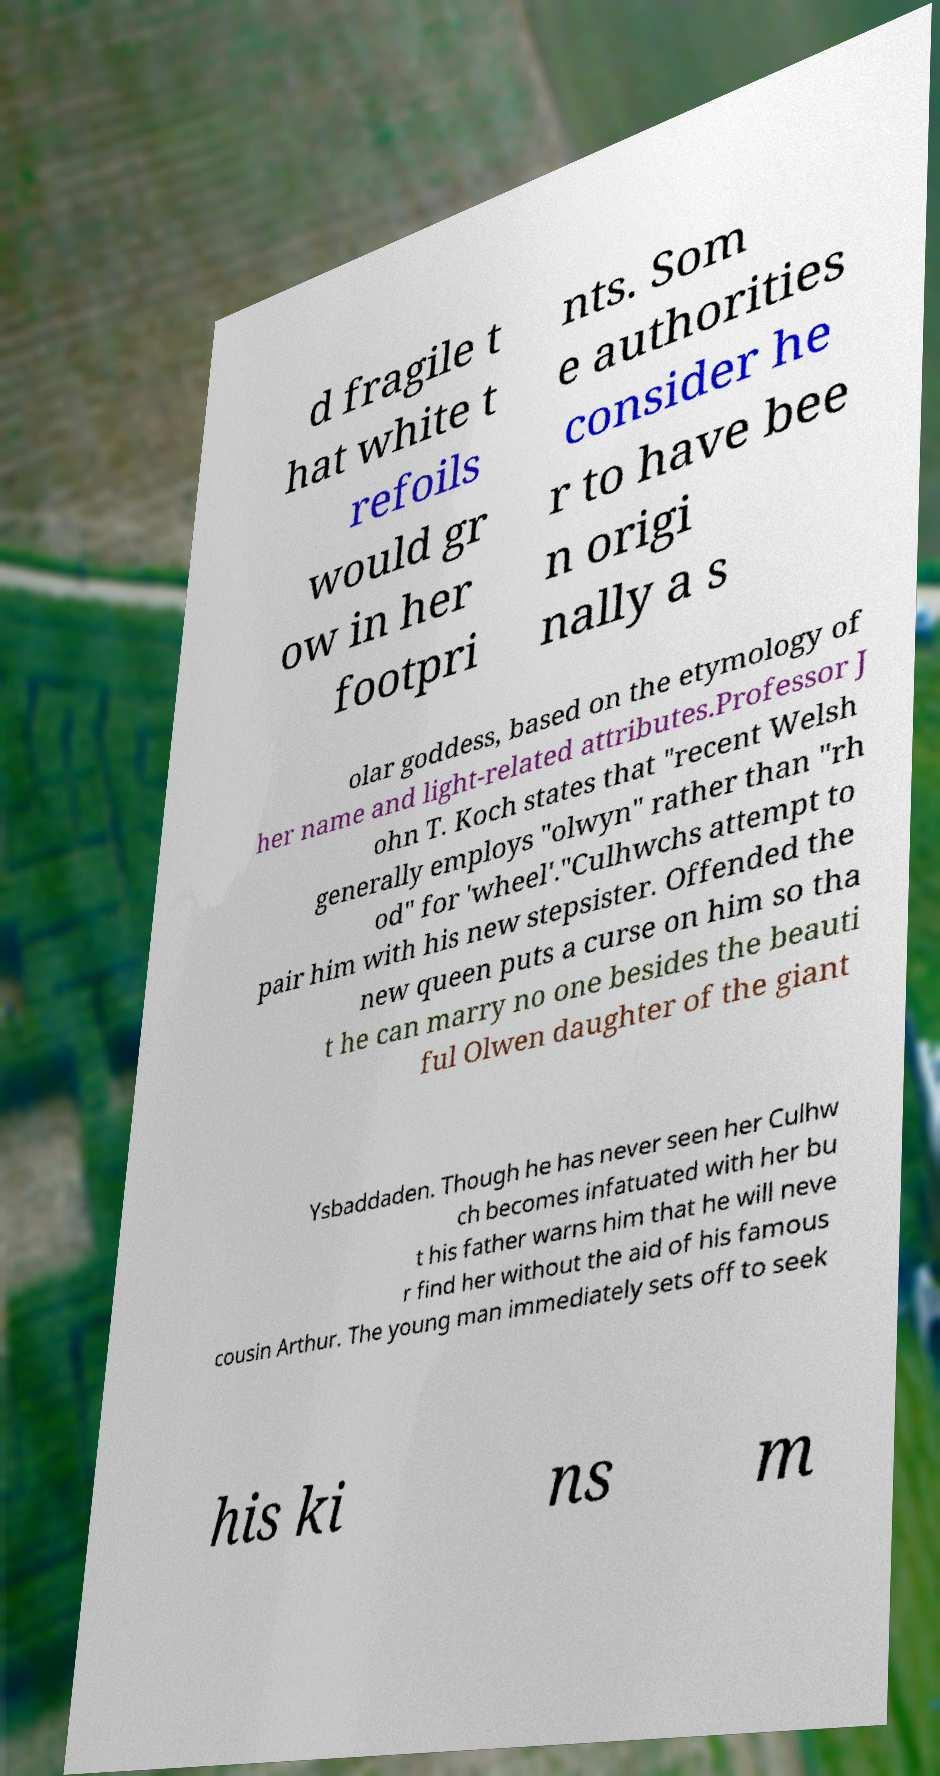Could you assist in decoding the text presented in this image and type it out clearly? d fragile t hat white t refoils would gr ow in her footpri nts. Som e authorities consider he r to have bee n origi nally a s olar goddess, based on the etymology of her name and light-related attributes.Professor J ohn T. Koch states that "recent Welsh generally employs "olwyn" rather than "rh od" for 'wheel'."Culhwchs attempt to pair him with his new stepsister. Offended the new queen puts a curse on him so tha t he can marry no one besides the beauti ful Olwen daughter of the giant Ysbaddaden. Though he has never seen her Culhw ch becomes infatuated with her bu t his father warns him that he will neve r find her without the aid of his famous cousin Arthur. The young man immediately sets off to seek his ki ns m 